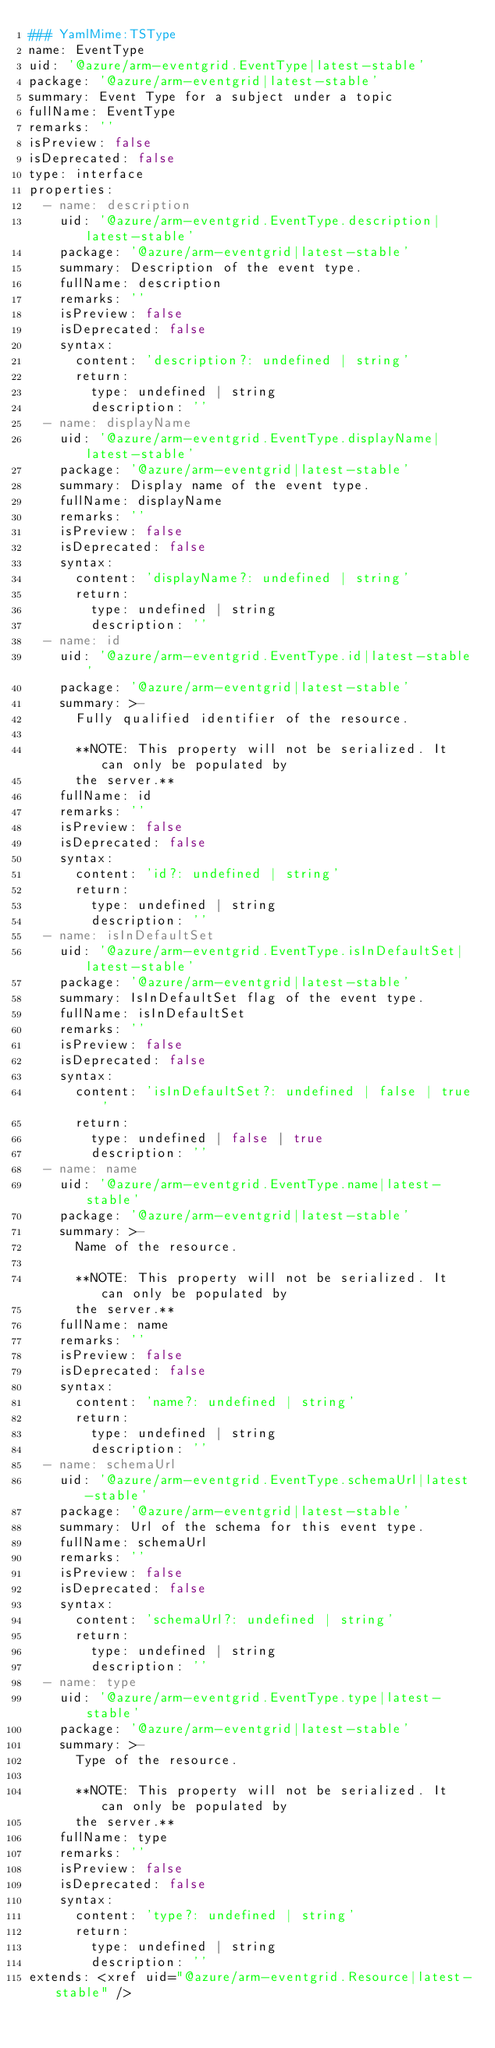Convert code to text. <code><loc_0><loc_0><loc_500><loc_500><_YAML_>### YamlMime:TSType
name: EventType
uid: '@azure/arm-eventgrid.EventType|latest-stable'
package: '@azure/arm-eventgrid|latest-stable'
summary: Event Type for a subject under a topic
fullName: EventType
remarks: ''
isPreview: false
isDeprecated: false
type: interface
properties:
  - name: description
    uid: '@azure/arm-eventgrid.EventType.description|latest-stable'
    package: '@azure/arm-eventgrid|latest-stable'
    summary: Description of the event type.
    fullName: description
    remarks: ''
    isPreview: false
    isDeprecated: false
    syntax:
      content: 'description?: undefined | string'
      return:
        type: undefined | string
        description: ''
  - name: displayName
    uid: '@azure/arm-eventgrid.EventType.displayName|latest-stable'
    package: '@azure/arm-eventgrid|latest-stable'
    summary: Display name of the event type.
    fullName: displayName
    remarks: ''
    isPreview: false
    isDeprecated: false
    syntax:
      content: 'displayName?: undefined | string'
      return:
        type: undefined | string
        description: ''
  - name: id
    uid: '@azure/arm-eventgrid.EventType.id|latest-stable'
    package: '@azure/arm-eventgrid|latest-stable'
    summary: >-
      Fully qualified identifier of the resource.

      **NOTE: This property will not be serialized. It can only be populated by
      the server.**
    fullName: id
    remarks: ''
    isPreview: false
    isDeprecated: false
    syntax:
      content: 'id?: undefined | string'
      return:
        type: undefined | string
        description: ''
  - name: isInDefaultSet
    uid: '@azure/arm-eventgrid.EventType.isInDefaultSet|latest-stable'
    package: '@azure/arm-eventgrid|latest-stable'
    summary: IsInDefaultSet flag of the event type.
    fullName: isInDefaultSet
    remarks: ''
    isPreview: false
    isDeprecated: false
    syntax:
      content: 'isInDefaultSet?: undefined | false | true'
      return:
        type: undefined | false | true
        description: ''
  - name: name
    uid: '@azure/arm-eventgrid.EventType.name|latest-stable'
    package: '@azure/arm-eventgrid|latest-stable'
    summary: >-
      Name of the resource.

      **NOTE: This property will not be serialized. It can only be populated by
      the server.**
    fullName: name
    remarks: ''
    isPreview: false
    isDeprecated: false
    syntax:
      content: 'name?: undefined | string'
      return:
        type: undefined | string
        description: ''
  - name: schemaUrl
    uid: '@azure/arm-eventgrid.EventType.schemaUrl|latest-stable'
    package: '@azure/arm-eventgrid|latest-stable'
    summary: Url of the schema for this event type.
    fullName: schemaUrl
    remarks: ''
    isPreview: false
    isDeprecated: false
    syntax:
      content: 'schemaUrl?: undefined | string'
      return:
        type: undefined | string
        description: ''
  - name: type
    uid: '@azure/arm-eventgrid.EventType.type|latest-stable'
    package: '@azure/arm-eventgrid|latest-stable'
    summary: >-
      Type of the resource.

      **NOTE: This property will not be serialized. It can only be populated by
      the server.**
    fullName: type
    remarks: ''
    isPreview: false
    isDeprecated: false
    syntax:
      content: 'type?: undefined | string'
      return:
        type: undefined | string
        description: ''
extends: <xref uid="@azure/arm-eventgrid.Resource|latest-stable" />
</code> 